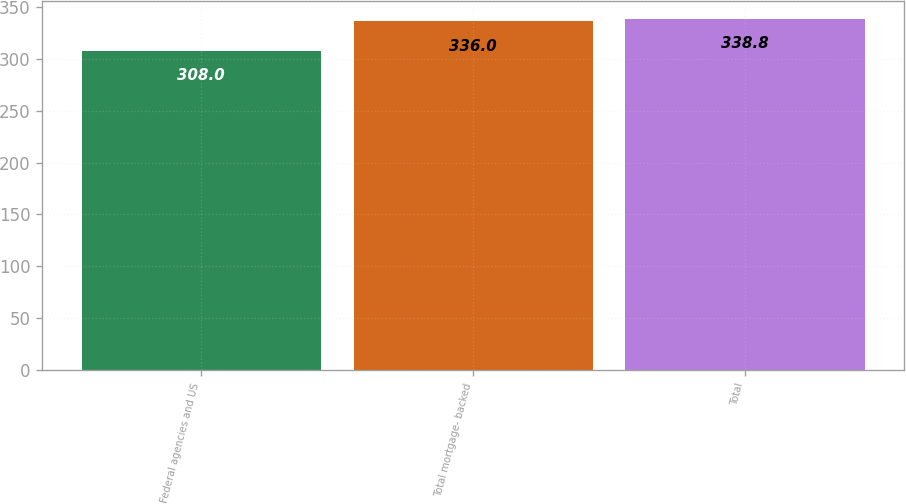Convert chart to OTSL. <chart><loc_0><loc_0><loc_500><loc_500><bar_chart><fcel>Federal agencies and US<fcel>Total mortgage- backed<fcel>Total<nl><fcel>308<fcel>336<fcel>338.8<nl></chart> 